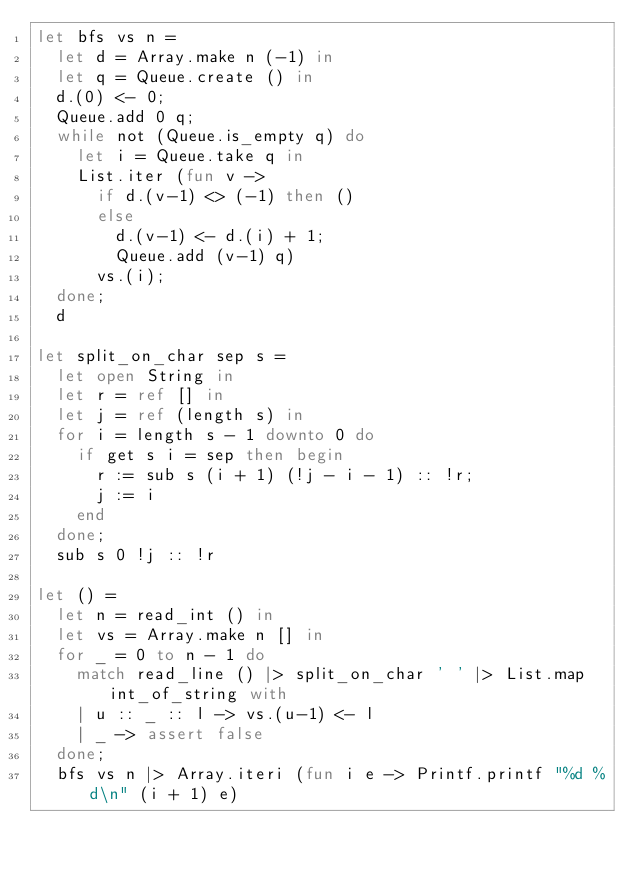<code> <loc_0><loc_0><loc_500><loc_500><_OCaml_>let bfs vs n =
  let d = Array.make n (-1) in
  let q = Queue.create () in
  d.(0) <- 0;
  Queue.add 0 q;
  while not (Queue.is_empty q) do
    let i = Queue.take q in
    List.iter (fun v ->
      if d.(v-1) <> (-1) then ()
      else
        d.(v-1) <- d.(i) + 1;
        Queue.add (v-1) q)
      vs.(i);
  done;
  d

let split_on_char sep s =
  let open String in
  let r = ref [] in
  let j = ref (length s) in
  for i = length s - 1 downto 0 do
    if get s i = sep then begin
      r := sub s (i + 1) (!j - i - 1) :: !r;
      j := i
    end
  done;
  sub s 0 !j :: !r

let () =
  let n = read_int () in
  let vs = Array.make n [] in
  for _ = 0 to n - 1 do
    match read_line () |> split_on_char ' ' |> List.map int_of_string with
    | u :: _ :: l -> vs.(u-1) <- l
    | _ -> assert false
  done;
  bfs vs n |> Array.iteri (fun i e -> Printf.printf "%d %d\n" (i + 1) e)</code> 